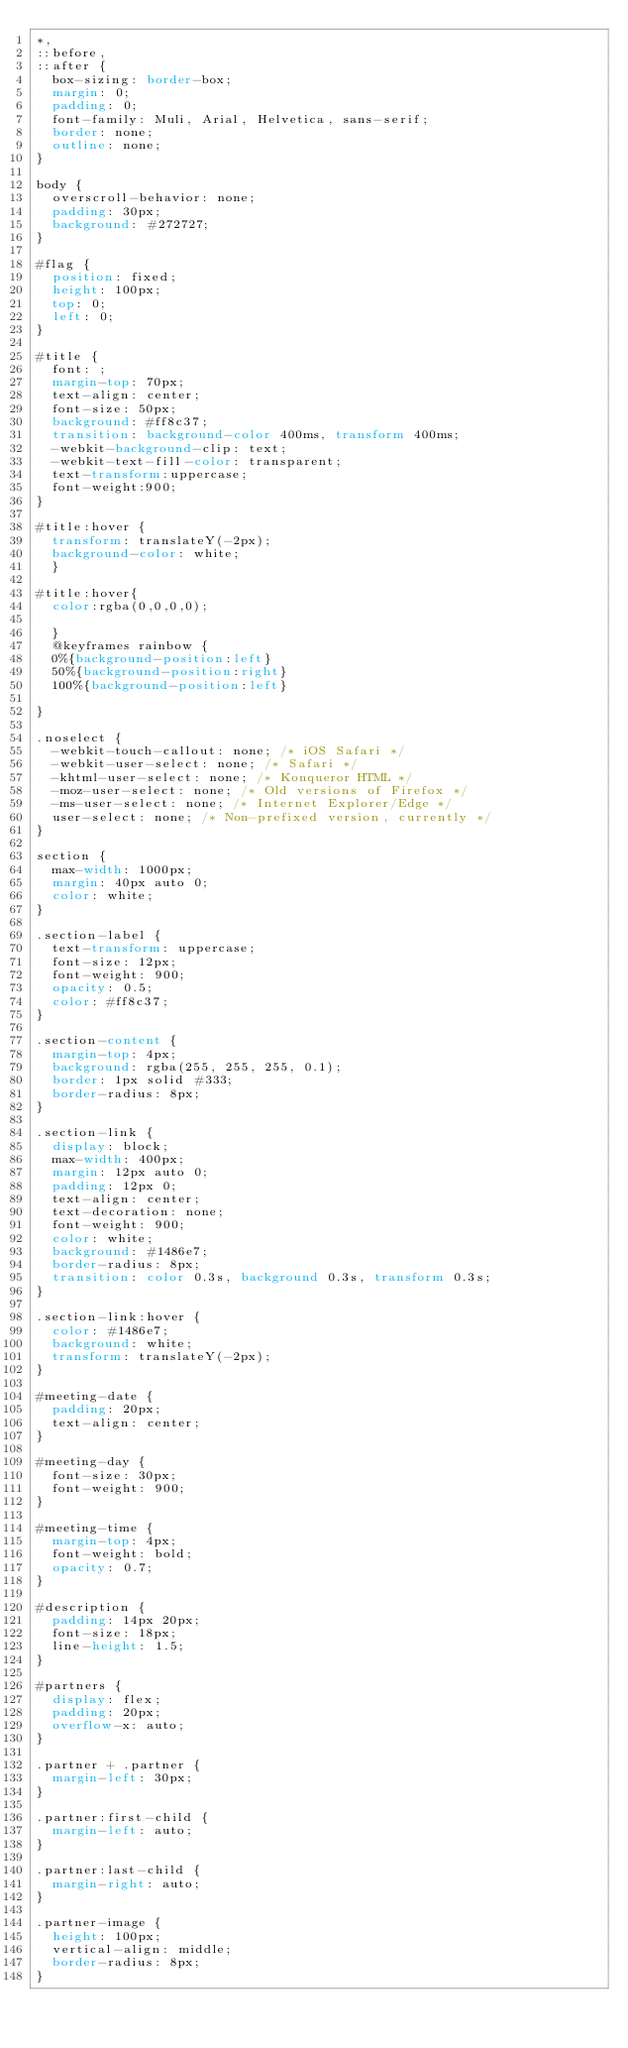Convert code to text. <code><loc_0><loc_0><loc_500><loc_500><_CSS_>*,
::before,
::after {
	box-sizing: border-box;
	margin: 0;
	padding: 0;
	font-family: Muli, Arial, Helvetica, sans-serif;
	border: none;
	outline: none;
}

body {
	overscroll-behavior: none;
	padding: 30px;
	background: #272727;
}

#flag {
	position: fixed;
	height: 100px;
	top: 0;
	left: 0;
}

#title {
	font: ;
	margin-top: 70px;
	text-align: center;
	font-size: 50px;
	background: #ff8c37;
	transition: background-color 400ms, transform 400ms;
	-webkit-background-clip: text;
	-webkit-text-fill-color: transparent;
	text-transform:uppercase;
	font-weight:900;
}

#title:hover {
	transform: translateY(-2px);
	background-color: white;
  }

#title:hover{
	color:rgba(0,0,0,0);

	}
	@keyframes rainbow { 
	0%{background-position:left}
	50%{background-position:right}
	100%{background-position:left}
	
}

.noselect {
	-webkit-touch-callout: none; /* iOS Safari */
	-webkit-user-select: none; /* Safari */
	-khtml-user-select: none; /* Konqueror HTML */
	-moz-user-select: none; /* Old versions of Firefox */
	-ms-user-select: none; /* Internet Explorer/Edge */
	user-select: none; /* Non-prefixed version, currently */
}

section {
	max-width: 1000px;
	margin: 40px auto 0;
	color: white;
}

.section-label {
	text-transform: uppercase;
	font-size: 12px;
	font-weight: 900;
	opacity: 0.5;
	color: #ff8c37;
}

.section-content {
	margin-top: 4px;
	background: rgba(255, 255, 255, 0.1);
	border: 1px solid #333;
	border-radius: 8px;
}

.section-link {
	display: block;
	max-width: 400px;
	margin: 12px auto 0;
	padding: 12px 0;
	text-align: center;
	text-decoration: none;
	font-weight: 900;
	color: white;
	background: #1486e7;
	border-radius: 8px;
	transition: color 0.3s, background 0.3s, transform 0.3s;
}

.section-link:hover {
	color: #1486e7;
	background: white;
	transform: translateY(-2px);
}

#meeting-date {
	padding: 20px;
	text-align: center;
}

#meeting-day {
	font-size: 30px;
	font-weight: 900;
}

#meeting-time {
	margin-top: 4px;
	font-weight: bold;
	opacity: 0.7;
}

#description {
	padding: 14px 20px;
	font-size: 18px;
	line-height: 1.5;
}

#partners {
	display: flex;
	padding: 20px;
	overflow-x: auto;
}

.partner + .partner {
	margin-left: 30px;
}

.partner:first-child {
	margin-left: auto;
}

.partner:last-child {
	margin-right: auto;
}

.partner-image {
	height: 100px;
	vertical-align: middle;
	border-radius: 8px;
}
</code> 